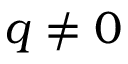Convert formula to latex. <formula><loc_0><loc_0><loc_500><loc_500>q \neq 0</formula> 